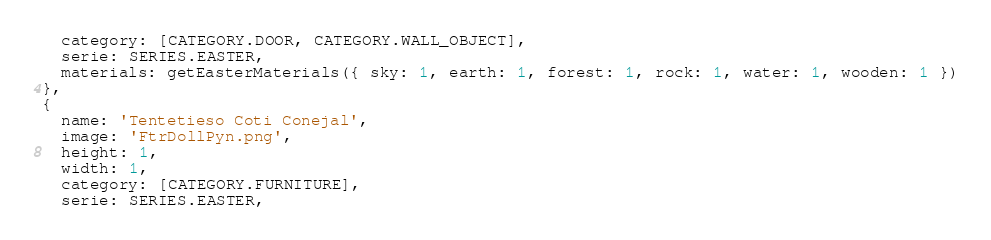<code> <loc_0><loc_0><loc_500><loc_500><_JavaScript_>  category: [CATEGORY.DOOR, CATEGORY.WALL_OBJECT],
  serie: SERIES.EASTER,
  materials: getEasterMaterials({ sky: 1, earth: 1, forest: 1, rock: 1, water: 1, wooden: 1 })
},
{
  name: 'Tentetieso Coti Conejal',
  image: 'FtrDollPyn.png',
  height: 1,
  width: 1,
  category: [CATEGORY.FURNITURE],
  serie: SERIES.EASTER,</code> 